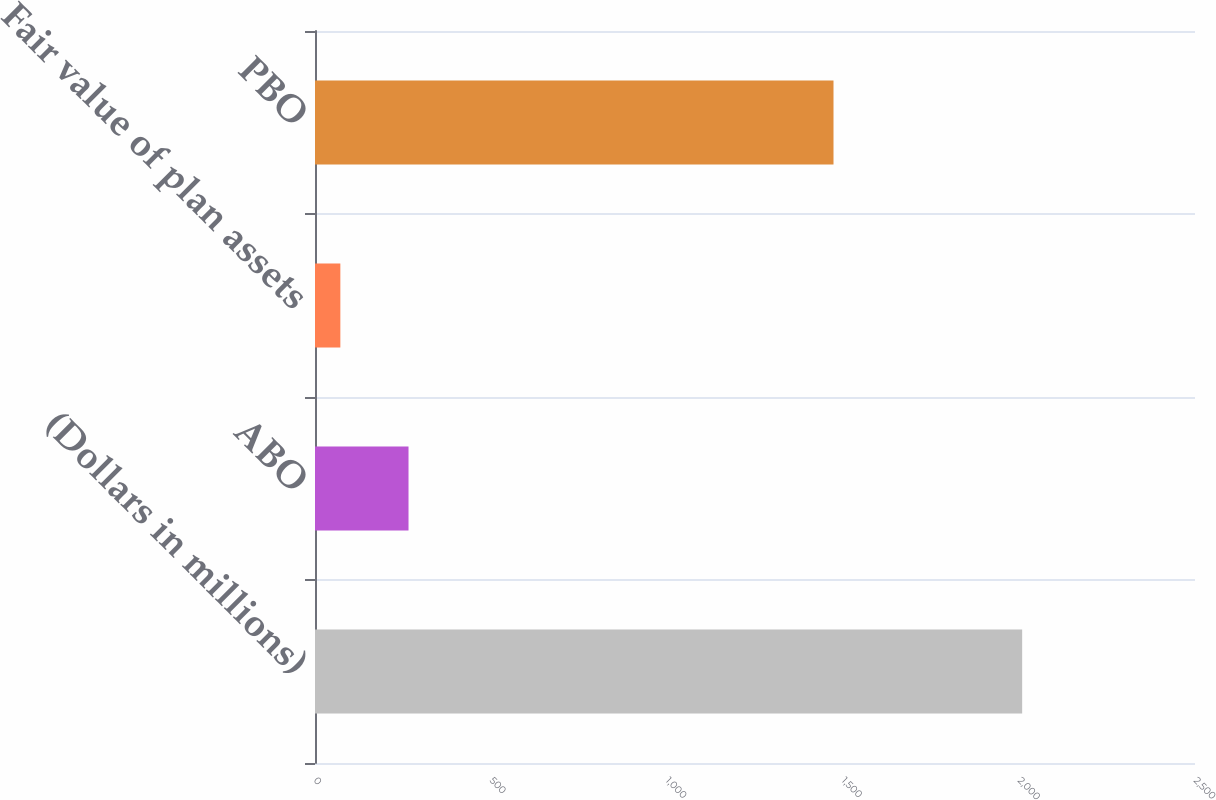Convert chart. <chart><loc_0><loc_0><loc_500><loc_500><bar_chart><fcel>(Dollars in millions)<fcel>ABO<fcel>Fair value of plan assets<fcel>PBO<nl><fcel>2009<fcel>265.7<fcel>72<fcel>1473<nl></chart> 